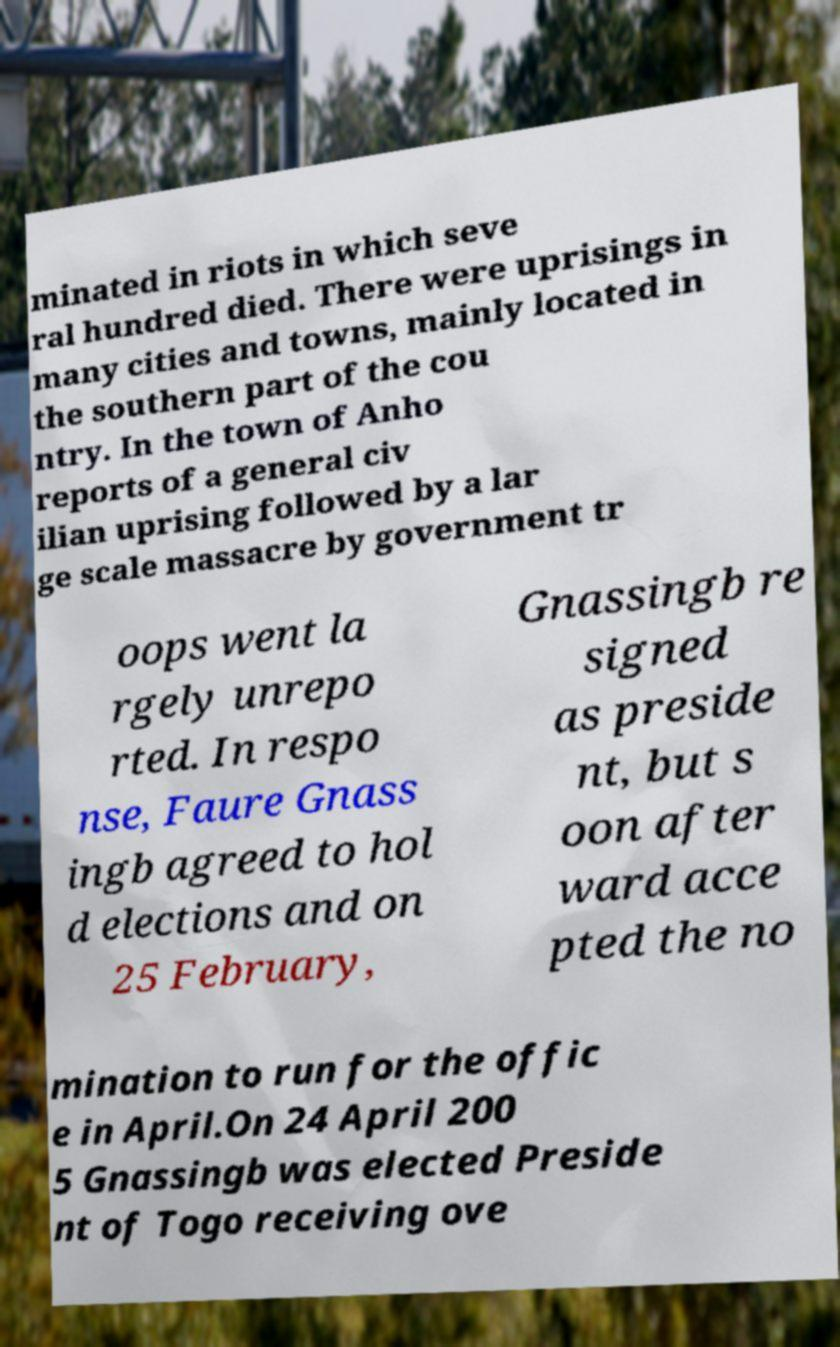Please read and relay the text visible in this image. What does it say? minated in riots in which seve ral hundred died. There were uprisings in many cities and towns, mainly located in the southern part of the cou ntry. In the town of Anho reports of a general civ ilian uprising followed by a lar ge scale massacre by government tr oops went la rgely unrepo rted. In respo nse, Faure Gnass ingb agreed to hol d elections and on 25 February, Gnassingb re signed as preside nt, but s oon after ward acce pted the no mination to run for the offic e in April.On 24 April 200 5 Gnassingb was elected Preside nt of Togo receiving ove 